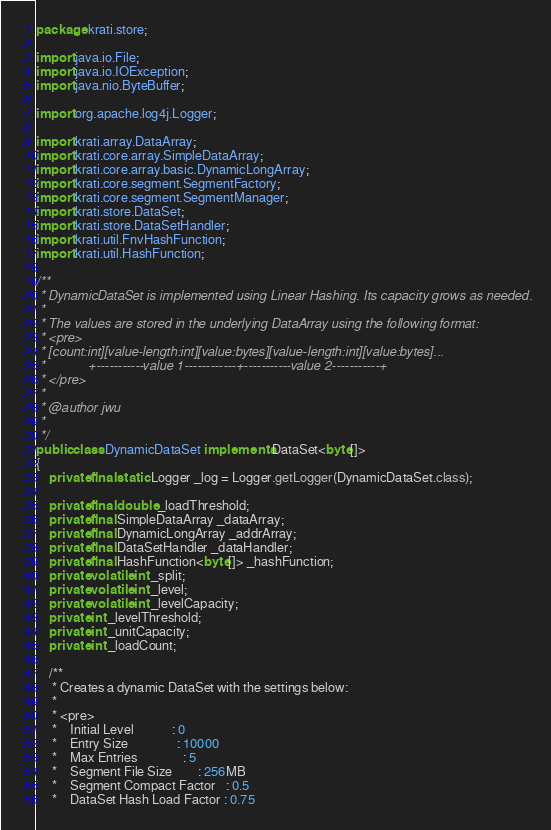Convert code to text. <code><loc_0><loc_0><loc_500><loc_500><_Java_>package krati.store;

import java.io.File;
import java.io.IOException;
import java.nio.ByteBuffer;

import org.apache.log4j.Logger;

import krati.array.DataArray;
import krati.core.array.SimpleDataArray;
import krati.core.array.basic.DynamicLongArray;
import krati.core.segment.SegmentFactory;
import krati.core.segment.SegmentManager;
import krati.store.DataSet;
import krati.store.DataSetHandler;
import krati.util.FnvHashFunction;
import krati.util.HashFunction;

/**
 * DynamicDataSet is implemented using Linear Hashing. Its capacity grows as needed.
 * 
 * The values are stored in the underlying DataArray using the following format:
 * <pre>
 * [count:int][value-length:int][value:bytes][value-length:int][value:bytes]...
 *            +-----------value 1------------+-----------value 2-----------+
 * </pre>
 * 
 * @author jwu
 *
 */
public class DynamicDataSet implements DataSet<byte[]>
{
    private final static Logger _log = Logger.getLogger(DynamicDataSet.class);
    
    private final double _loadThreshold;
    private final SimpleDataArray _dataArray;
    private final DynamicLongArray _addrArray;
    private final DataSetHandler _dataHandler;
    private final HashFunction<byte[]> _hashFunction;
    private volatile int _split;
    private volatile int _level;
    private volatile int _levelCapacity;
    private int _levelThreshold;
    private int _unitCapacity;
    private int _loadCount;
    
    /**
     * Creates a dynamic DataSet with the settings below:
     * 
     * <pre>
     *    Initial Level            : 0
     *    Entry Size               : 10000
     *    Max Entries              : 5
     *    Segment File Size        : 256MB
     *    Segment Compact Factor   : 0.5
     *    DataSet Hash Load Factor : 0.75</code> 